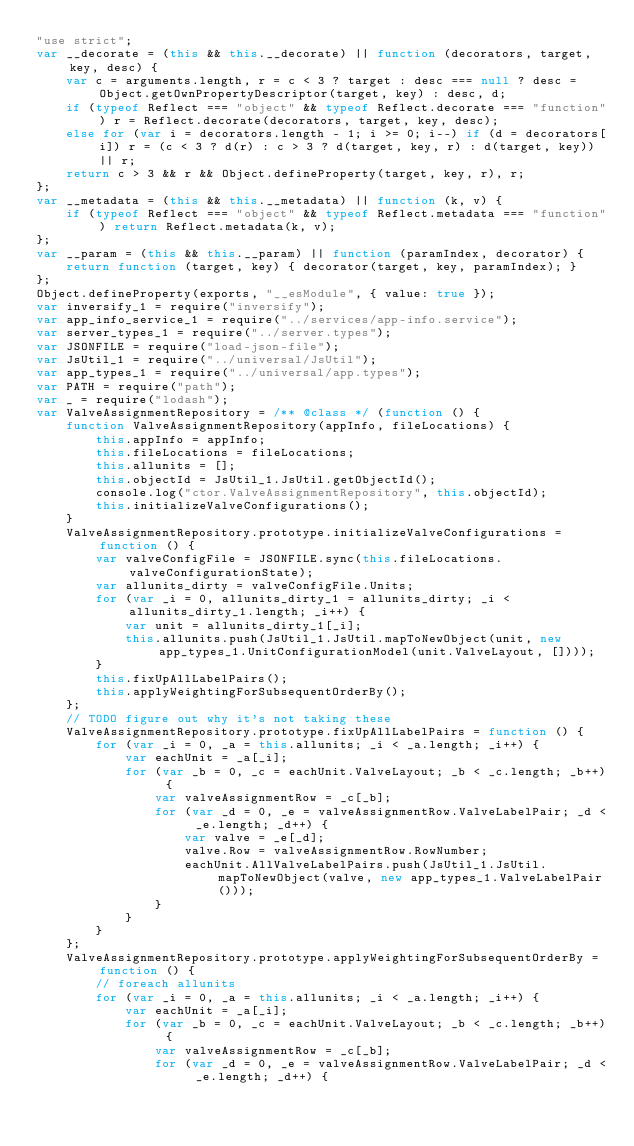<code> <loc_0><loc_0><loc_500><loc_500><_JavaScript_>"use strict";
var __decorate = (this && this.__decorate) || function (decorators, target, key, desc) {
    var c = arguments.length, r = c < 3 ? target : desc === null ? desc = Object.getOwnPropertyDescriptor(target, key) : desc, d;
    if (typeof Reflect === "object" && typeof Reflect.decorate === "function") r = Reflect.decorate(decorators, target, key, desc);
    else for (var i = decorators.length - 1; i >= 0; i--) if (d = decorators[i]) r = (c < 3 ? d(r) : c > 3 ? d(target, key, r) : d(target, key)) || r;
    return c > 3 && r && Object.defineProperty(target, key, r), r;
};
var __metadata = (this && this.__metadata) || function (k, v) {
    if (typeof Reflect === "object" && typeof Reflect.metadata === "function") return Reflect.metadata(k, v);
};
var __param = (this && this.__param) || function (paramIndex, decorator) {
    return function (target, key) { decorator(target, key, paramIndex); }
};
Object.defineProperty(exports, "__esModule", { value: true });
var inversify_1 = require("inversify");
var app_info_service_1 = require("../services/app-info.service");
var server_types_1 = require("../server.types");
var JSONFILE = require("load-json-file");
var JsUtil_1 = require("../universal/JsUtil");
var app_types_1 = require("../universal/app.types");
var PATH = require("path");
var _ = require("lodash");
var ValveAssignmentRepository = /** @class */ (function () {
    function ValveAssignmentRepository(appInfo, fileLocations) {
        this.appInfo = appInfo;
        this.fileLocations = fileLocations;
        this.allunits = [];
        this.objectId = JsUtil_1.JsUtil.getObjectId();
        console.log("ctor.ValveAssignmentRepository", this.objectId);
        this.initializeValveConfigurations();
    }
    ValveAssignmentRepository.prototype.initializeValveConfigurations = function () {
        var valveConfigFile = JSONFILE.sync(this.fileLocations.valveConfigurationState);
        var allunits_dirty = valveConfigFile.Units;
        for (var _i = 0, allunits_dirty_1 = allunits_dirty; _i < allunits_dirty_1.length; _i++) {
            var unit = allunits_dirty_1[_i];
            this.allunits.push(JsUtil_1.JsUtil.mapToNewObject(unit, new app_types_1.UnitConfigurationModel(unit.ValveLayout, [])));
        }
        this.fixUpAllLabelPairs();
        this.applyWeightingForSubsequentOrderBy();
    };
    // TODO figure out why it's not taking these
    ValveAssignmentRepository.prototype.fixUpAllLabelPairs = function () {
        for (var _i = 0, _a = this.allunits; _i < _a.length; _i++) {
            var eachUnit = _a[_i];
            for (var _b = 0, _c = eachUnit.ValveLayout; _b < _c.length; _b++) {
                var valveAssignmentRow = _c[_b];
                for (var _d = 0, _e = valveAssignmentRow.ValveLabelPair; _d < _e.length; _d++) {
                    var valve = _e[_d];
                    valve.Row = valveAssignmentRow.RowNumber;
                    eachUnit.AllValveLabelPairs.push(JsUtil_1.JsUtil.mapToNewObject(valve, new app_types_1.ValveLabelPair()));
                }
            }
        }
    };
    ValveAssignmentRepository.prototype.applyWeightingForSubsequentOrderBy = function () {
        // foreach allunits
        for (var _i = 0, _a = this.allunits; _i < _a.length; _i++) {
            var eachUnit = _a[_i];
            for (var _b = 0, _c = eachUnit.ValveLayout; _b < _c.length; _b++) {
                var valveAssignmentRow = _c[_b];
                for (var _d = 0, _e = valveAssignmentRow.ValveLabelPair; _d < _e.length; _d++) {</code> 